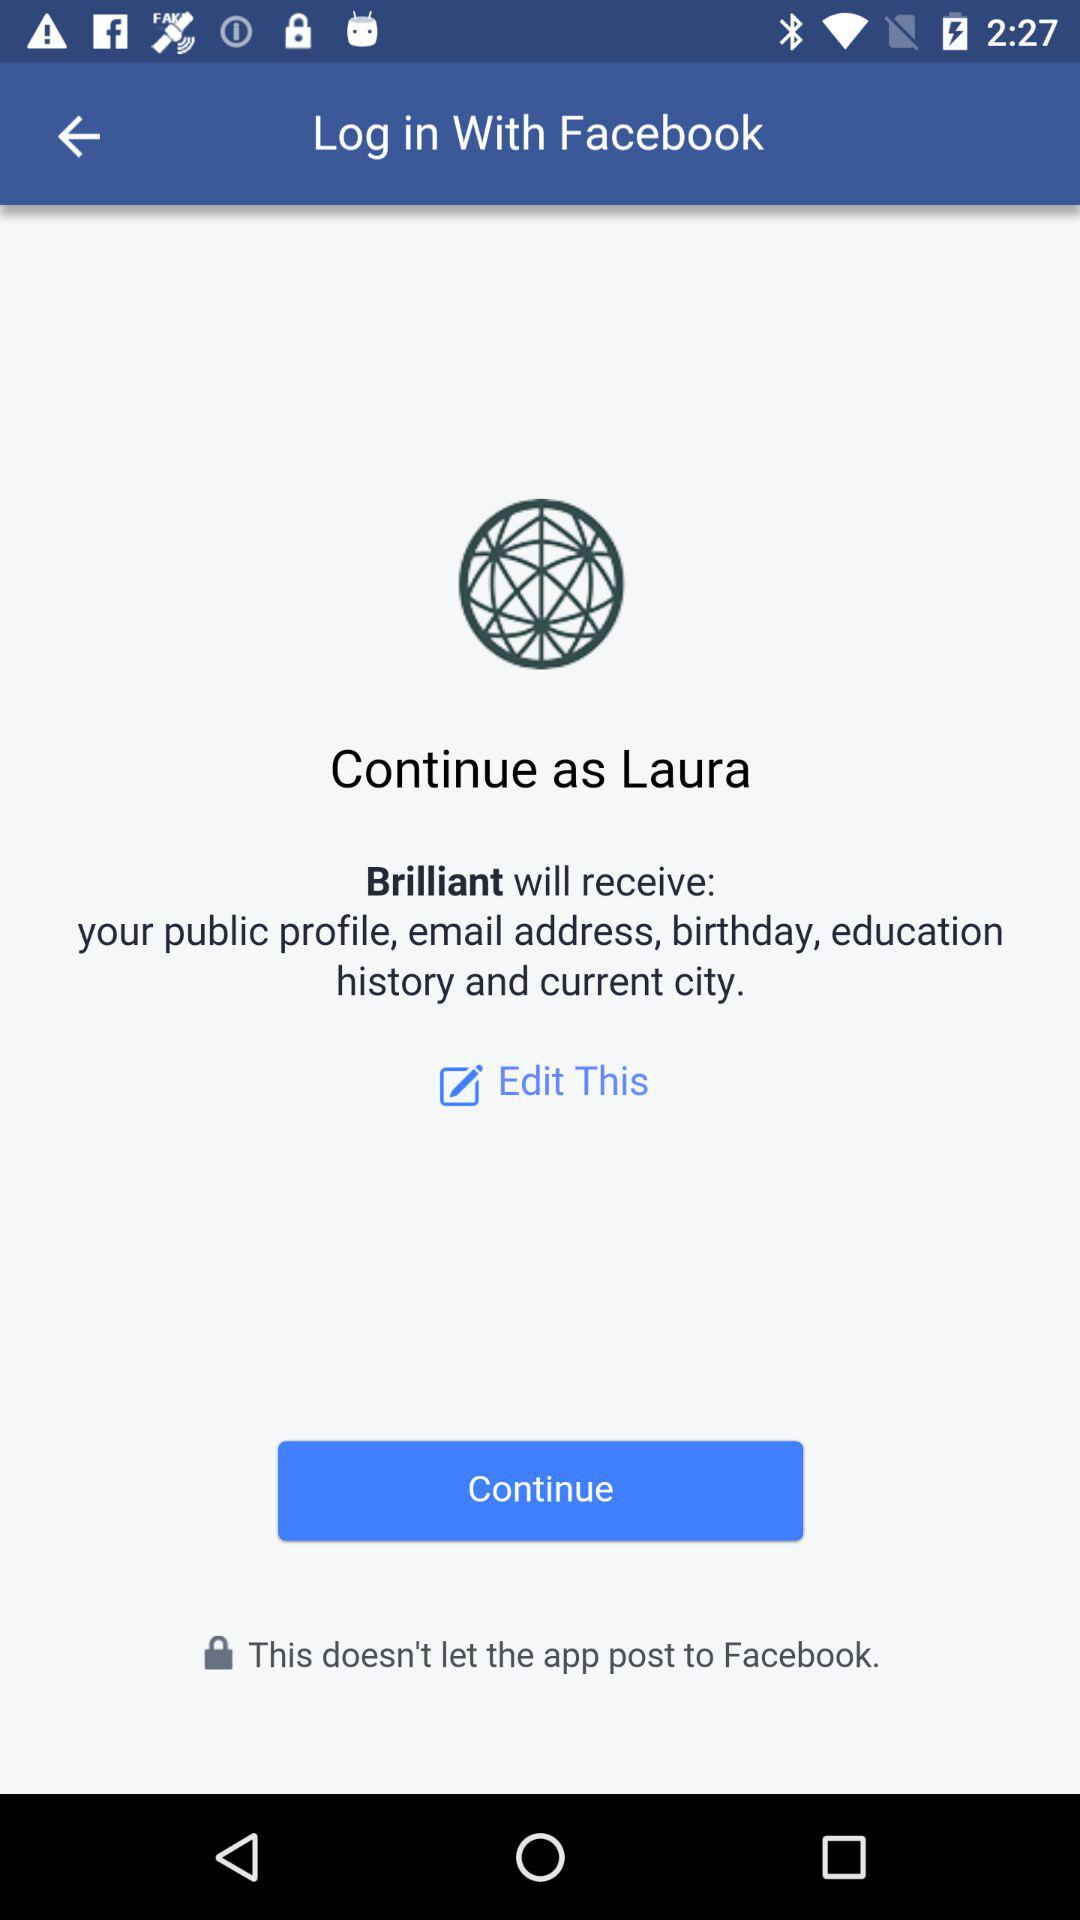Which option is selected?
When the provided information is insufficient, respond with <no answer>. <no answer> 